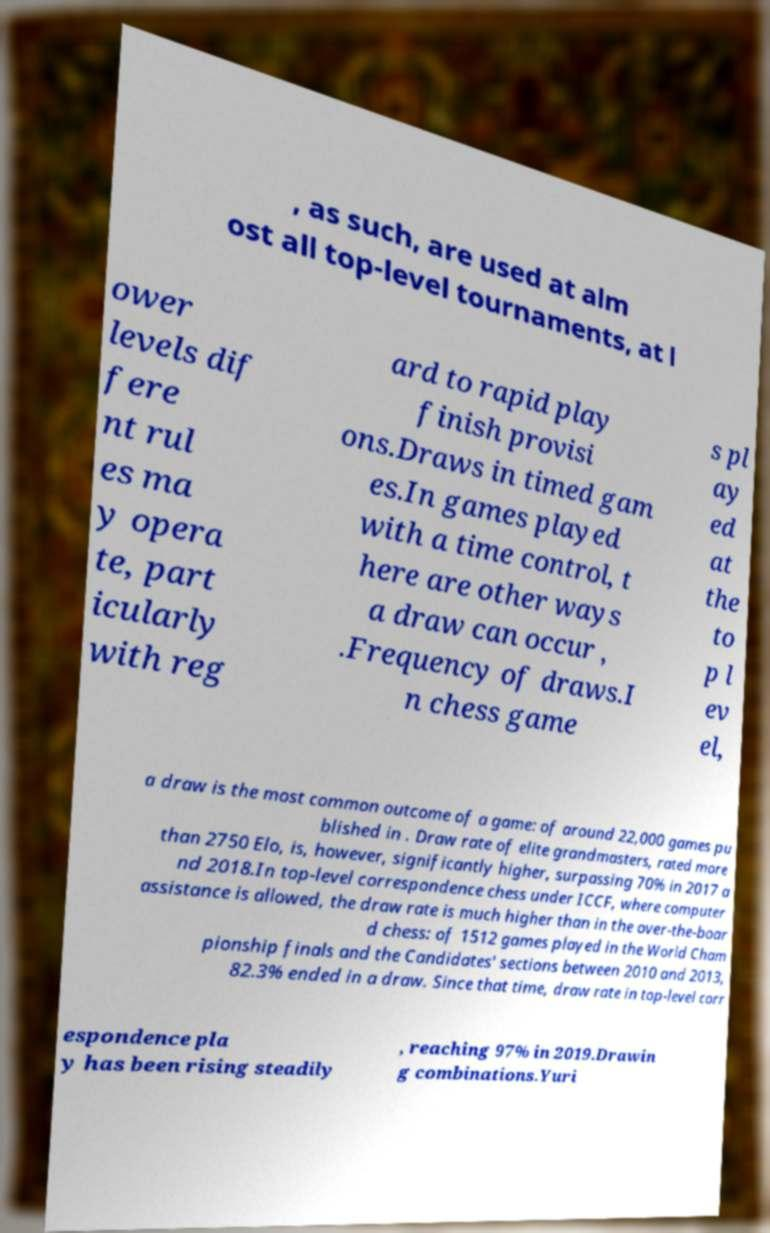I need the written content from this picture converted into text. Can you do that? , as such, are used at alm ost all top-level tournaments, at l ower levels dif fere nt rul es ma y opera te, part icularly with reg ard to rapid play finish provisi ons.Draws in timed gam es.In games played with a time control, t here are other ways a draw can occur , .Frequency of draws.I n chess game s pl ay ed at the to p l ev el, a draw is the most common outcome of a game: of around 22,000 games pu blished in . Draw rate of elite grandmasters, rated more than 2750 Elo, is, however, significantly higher, surpassing 70% in 2017 a nd 2018.In top-level correspondence chess under ICCF, where computer assistance is allowed, the draw rate is much higher than in the over-the-boar d chess: of 1512 games played in the World Cham pionship finals and the Candidates' sections between 2010 and 2013, 82.3% ended in a draw. Since that time, draw rate in top-level corr espondence pla y has been rising steadily , reaching 97% in 2019.Drawin g combinations.Yuri 